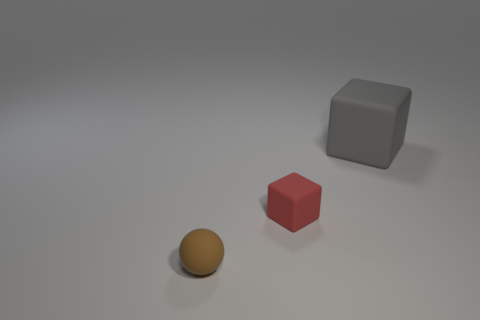Add 1 large purple balls. How many objects exist? 4 Subtract 1 balls. How many balls are left? 0 Add 3 big green rubber blocks. How many big green rubber blocks exist? 3 Subtract 0 purple balls. How many objects are left? 3 Subtract all cubes. How many objects are left? 1 Subtract all yellow spheres. Subtract all purple cylinders. How many spheres are left? 1 Subtract all red cylinders. How many gray cubes are left? 1 Subtract all tiny brown balls. Subtract all gray rubber blocks. How many objects are left? 1 Add 3 tiny brown objects. How many tiny brown objects are left? 4 